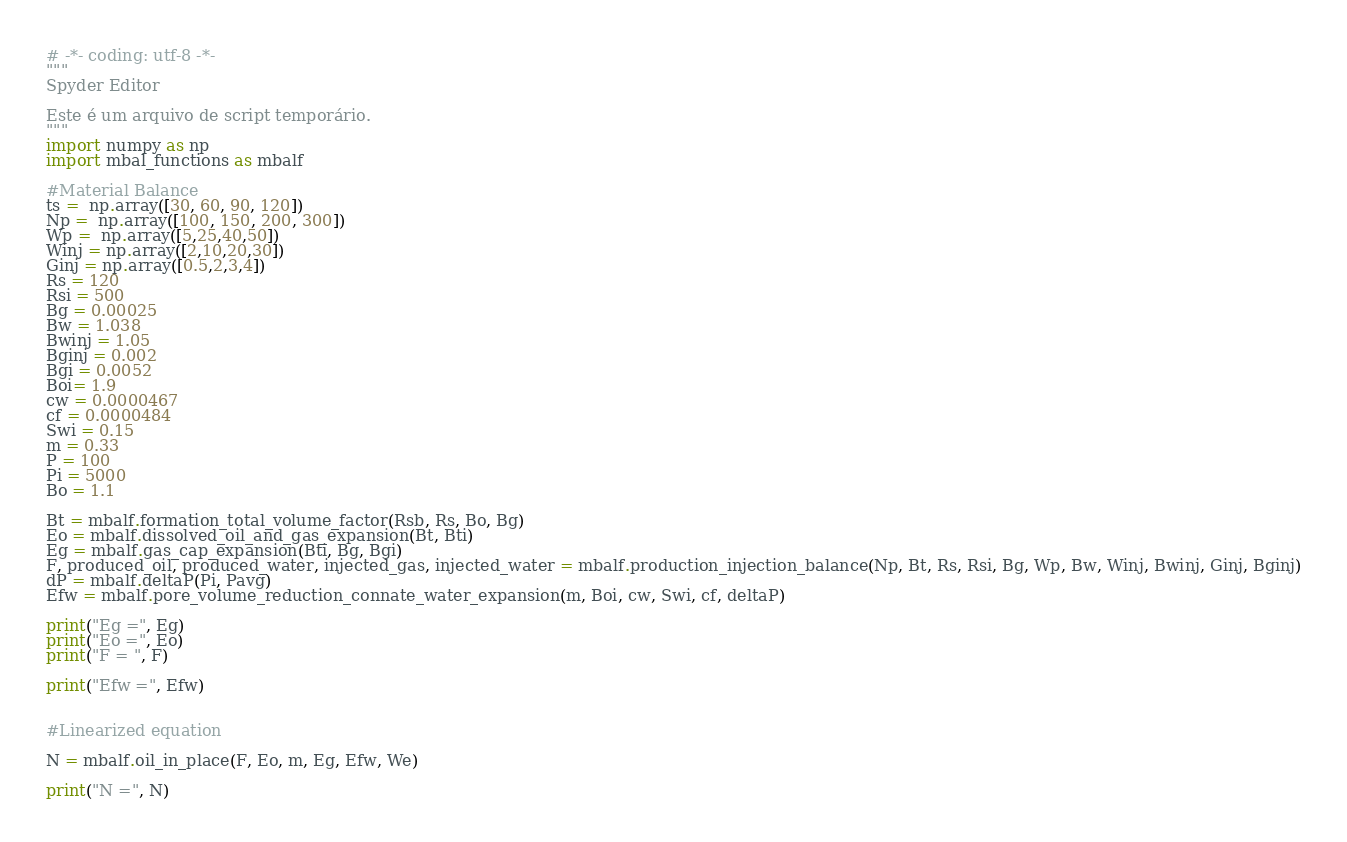Convert code to text. <code><loc_0><loc_0><loc_500><loc_500><_Python_># -*- coding: utf-8 -*-
"""
Spyder Editor

Este é um arquivo de script temporário.
"""
import numpy as np
import mbal_functions as mbalf

#Material Balance
ts =  np.array([30, 60, 90, 120])
Np =  np.array([100, 150, 200, 300])
Wp =  np.array([5,25,40,50])
Winj = np.array([2,10,20,30])
Ginj = np.array([0.5,2,3,4])
Rs = 120
Rsi = 500
Bg = 0.00025
Bw = 1.038
Bwinj = 1.05
Bginj = 0.002
Bgi = 0.0052
Boi= 1.9
cw = 0.0000467
cf = 0.0000484
Swi = 0.15
m = 0.33
P = 100 
Pi = 5000
Bo = 1.1

Bt = mbalf.formation_total_volume_factor(Rsb, Rs, Bo, Bg)
Eo = mbalf.dissolved_oil_and_gas_expansion(Bt, Bti)
Eg = mbalf.gas_cap_expansion(Bti, Bg, Bgi)
F, produced_oil, produced_water, injected_gas, injected_water = mbalf.production_injection_balance(Np, Bt, Rs, Rsi, Bg, Wp, Bw, Winj, Bwinj, Ginj, Bginj)
dP = mbalf.deltaP(Pi, Pavg)
Efw = mbalf.pore_volume_reduction_connate_water_expansion(m, Boi, cw, Swi, cf, deltaP)

print("Eg =", Eg)
print("Eo =", Eo)
print("F = ", F)

print("Efw =", Efw)


#Linearized equation

N = mbalf.oil_in_place(F, Eo, m, Eg, Efw, We)

print("N =", N)





</code> 